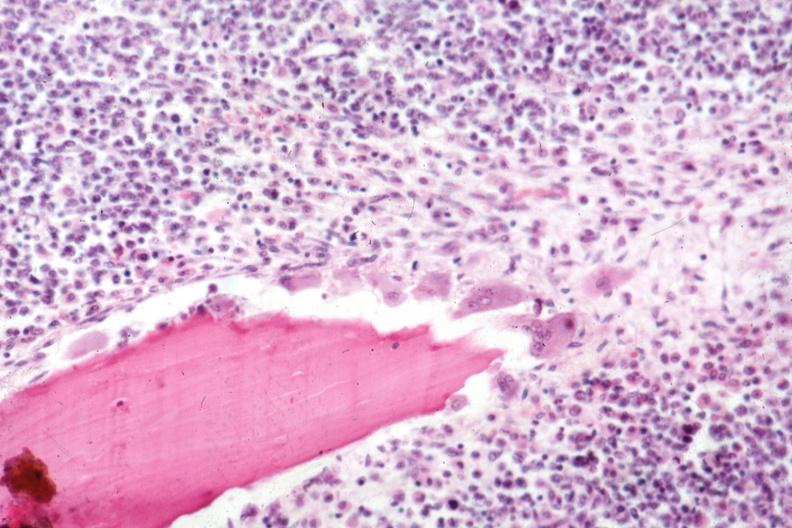how is osteoclasts shown marrow diffuse infiltration with lymphoma?
Answer the question using a single word or phrase. Malignant 